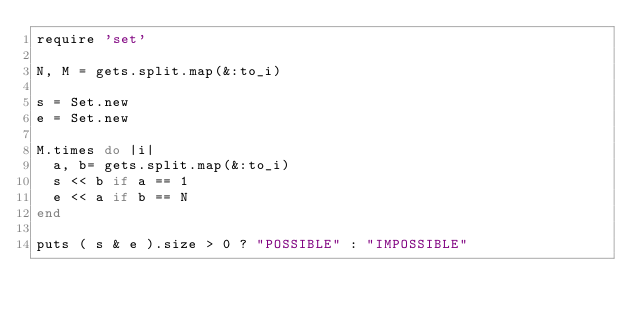<code> <loc_0><loc_0><loc_500><loc_500><_Ruby_>require 'set'

N, M = gets.split.map(&:to_i)

s = Set.new
e = Set.new

M.times do |i|
  a, b= gets.split.map(&:to_i)
  s << b if a == 1
  e << a if b == N
end

puts ( s & e ).size > 0 ? "POSSIBLE" : "IMPOSSIBLE"</code> 